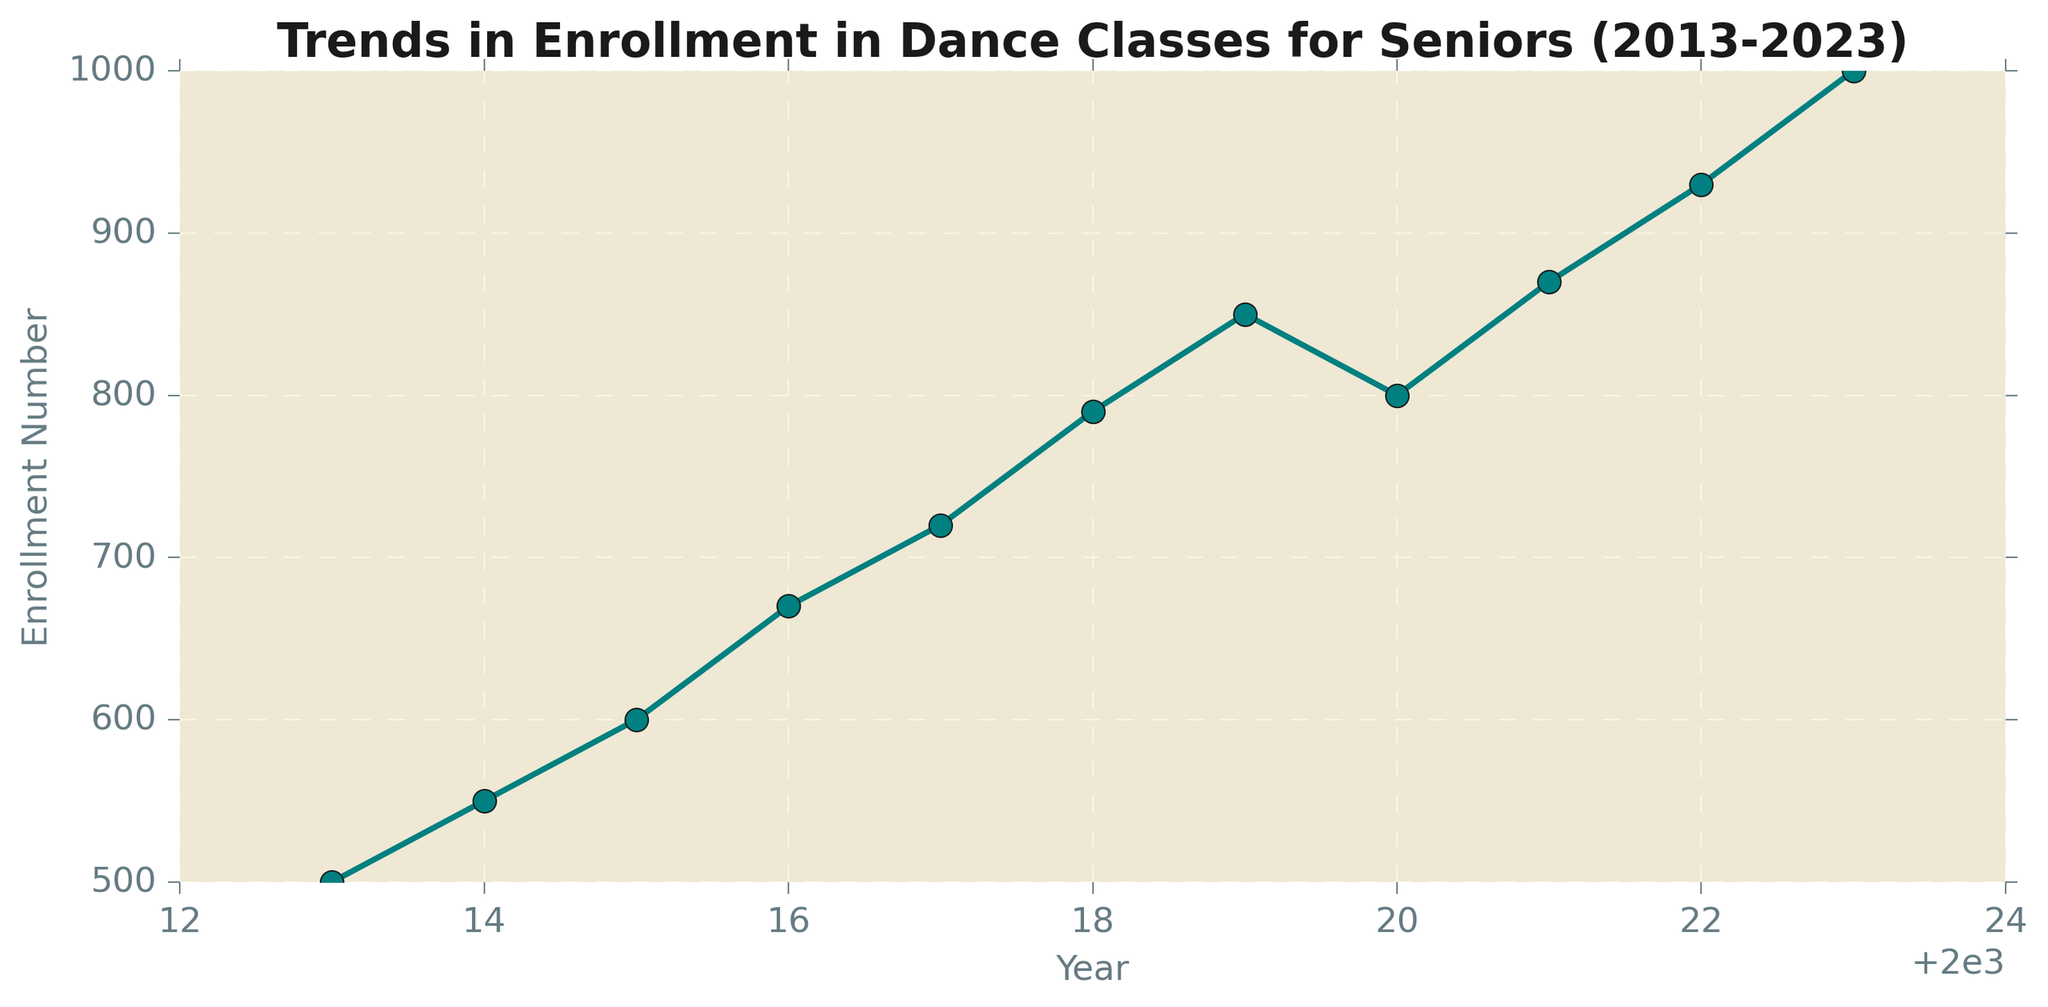What's the general trend in enrollment in dance classes for seniors from 2013 to 2023? To determine the general trend, observe the line from 2013 to 2023. The line shows an overall increase in enrollment numbers over the decade.
Answer: Increasing trend What was the enrollment number in 2015? Look at the data point corresponding to the year 2015 on the x-axis. The y-axis value for 2015 is 600.
Answer: 600 Which year had the highest enrollment number? Identify the highest point on the graph. The peak is at the year 2023 with an enrollment of 1000.
Answer: 2023 How many years saw a decline in enrollment numbers? Look for any downward slopes in the graph. The only decline occurs from 2019 (850) to 2020 (800).
Answer: 1 year What is the total increase in enrollment from 2013 to 2023? Subtract the enrollment number in 2013 (500) from that in 2023 (1000). The total increase is 1000 - 500 = 500.
Answer: 500 How does the enrollment in 2022 compare to that in 2017? Compare the y-axis values for 2022 and 2017. Enrollment in 2022 is 930, while in 2017 it was 720. Therefore, 2022 had a higher enrollment.
Answer: Higher in 2022 What is the average enrollment number over the 10 years? Sum all enrollment numbers and divide by the number of years. (500 + 550 + 600 + 670 + 720 + 790 + 850 + 800 + 870 + 930 + 1000) / 11 = 728.2
Answer: 728.2 Which year saw the largest single-year increase in enrollment? Calculate the yearly differences and find the biggest one: 
2014-2013 = 50,
2015-2014 = 50,
2016-2015 = 70,
2017-2016 = 50,
2018-2017 = 70,
2019-2018 = 60,
2020-2019 = -50,
2021-2020 = 70,
2022-2021 = 60,
2023-2022 = 70.
The biggest increase occurs in 3 years: 2016, 2018, 2021, 2023 (70 each).
Answer: 2016, 2018, 2021, 2023 What can you infer about the enrollment trend during the years 2020 and 2021? The graph shows a drop from 2019 (850) to 2020 (800) followed by an increase from 2020 (800) to 2021 (870). This suggests there might have been a specific event or circumstance in 2020 that caused a temporary decline, which rebounded in 2021.
Answer: Declined, then rebounded 